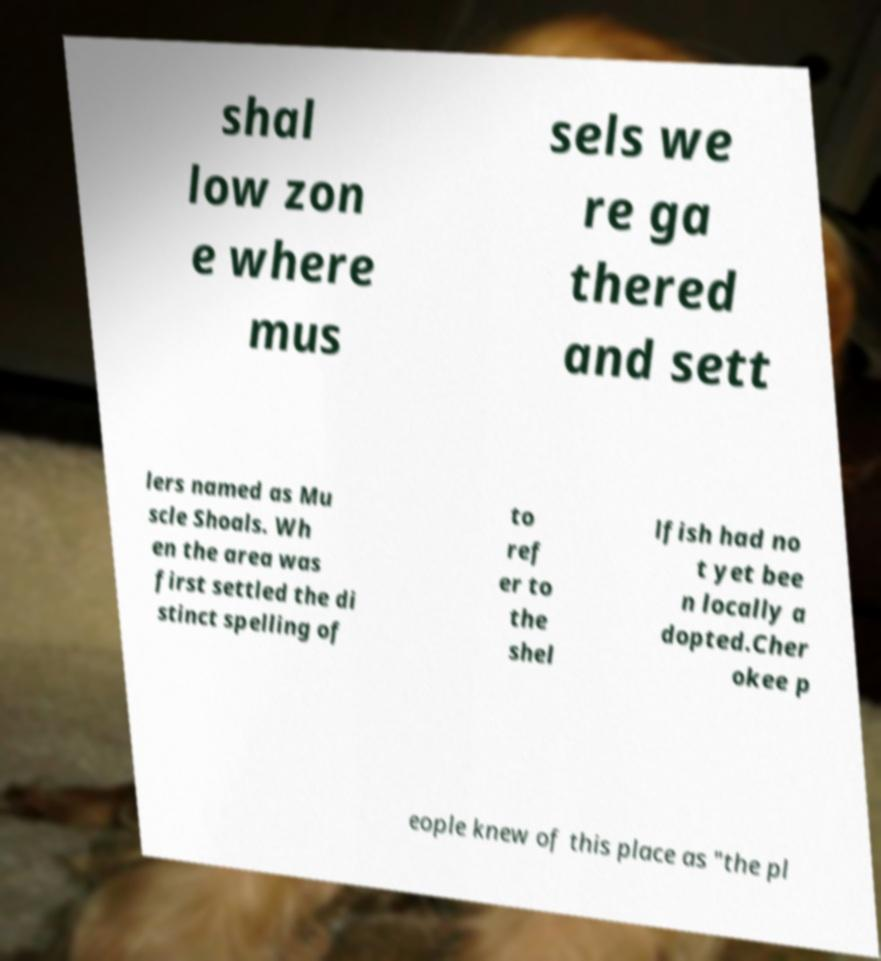Please identify and transcribe the text found in this image. shal low zon e where mus sels we re ga thered and sett lers named as Mu scle Shoals. Wh en the area was first settled the di stinct spelling of to ref er to the shel lfish had no t yet bee n locally a dopted.Cher okee p eople knew of this place as "the pl 